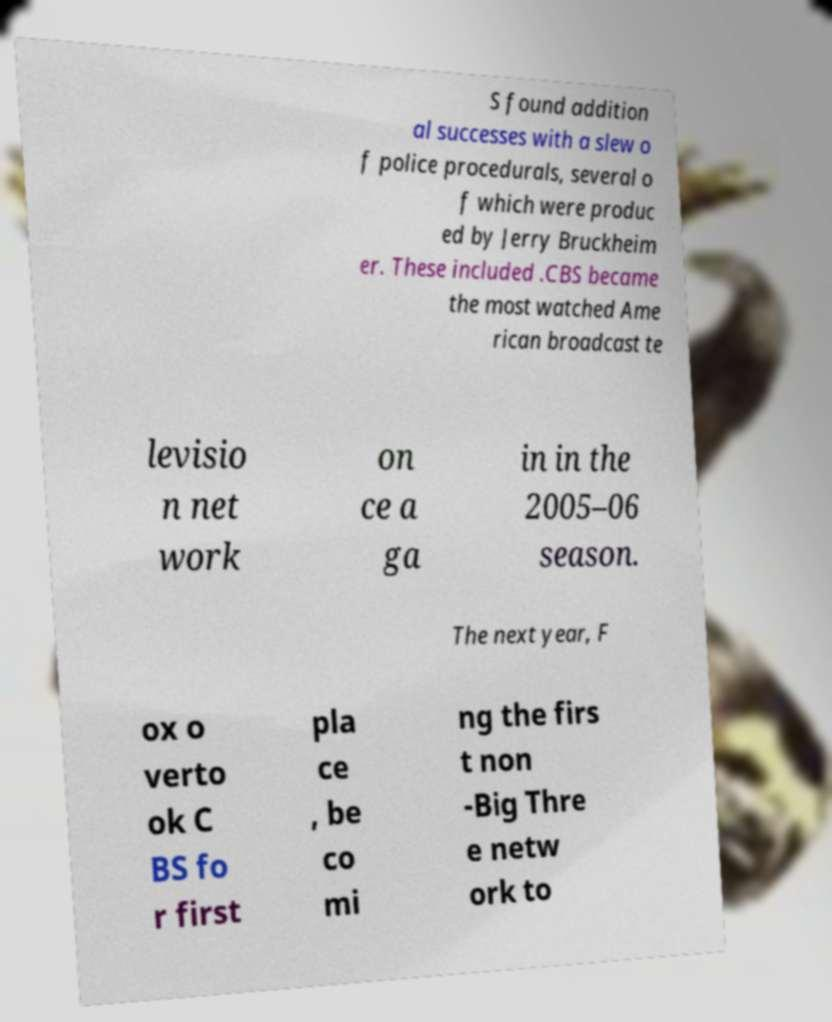I need the written content from this picture converted into text. Can you do that? S found addition al successes with a slew o f police procedurals, several o f which were produc ed by Jerry Bruckheim er. These included .CBS became the most watched Ame rican broadcast te levisio n net work on ce a ga in in the 2005–06 season. The next year, F ox o verto ok C BS fo r first pla ce , be co mi ng the firs t non -Big Thre e netw ork to 